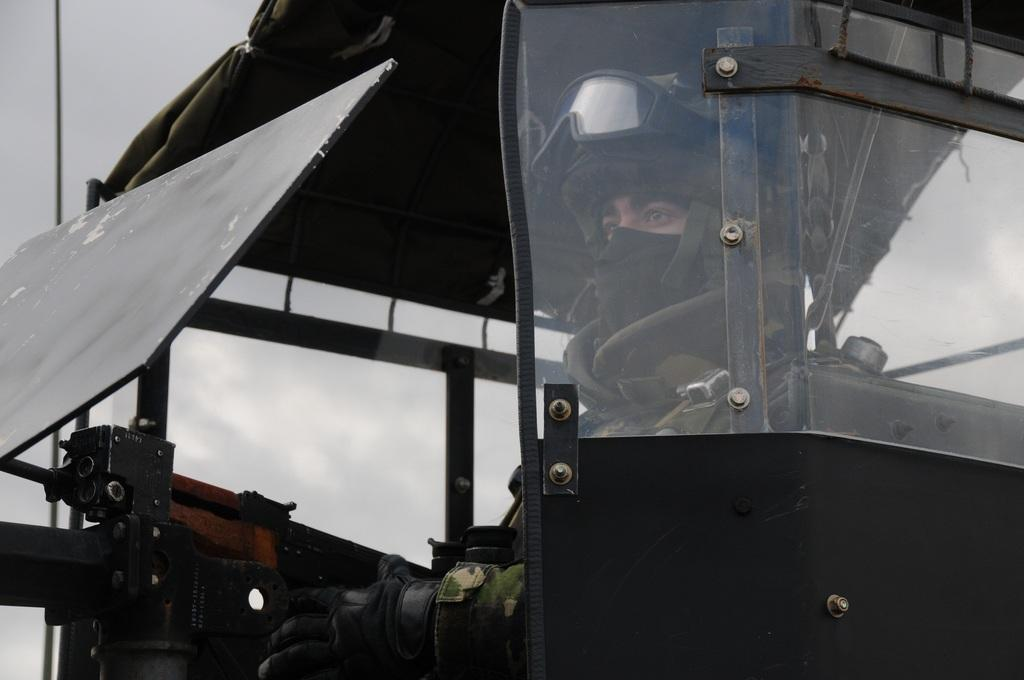What is the person in the image doing? The person is sitting in a vehicle. What is the person holding in the image? The person is in front of a gun. What protective gear is the person wearing? The person is wearing a helmet. What type of eyewear is the person wearing? The person is wearing spectacles. What can be seen in the background of the image? There is a sky visible in the background. What type of duck can be seen eating an apple at the party in the image? There is no duck, apple, or party present in the image. 